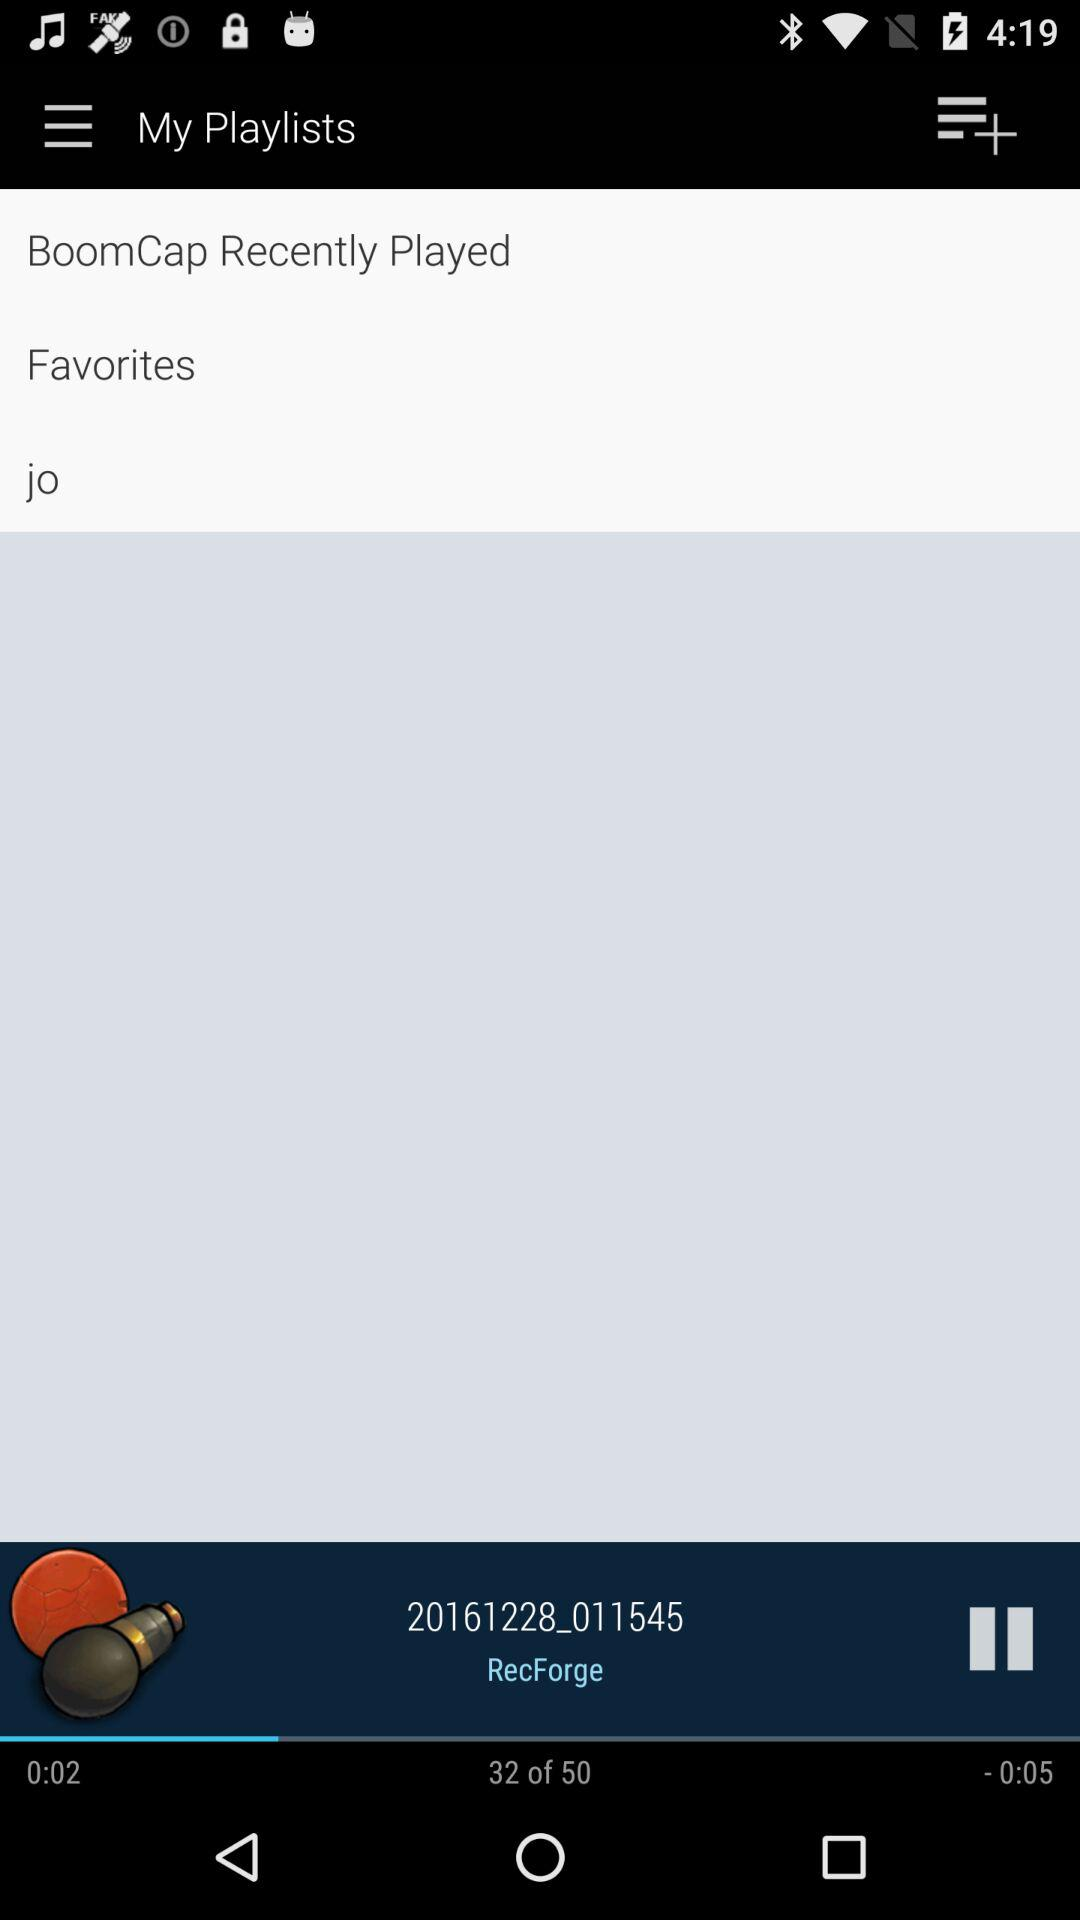What is the name of the current playing song? The name of the current playing song is "20161228_011545". 